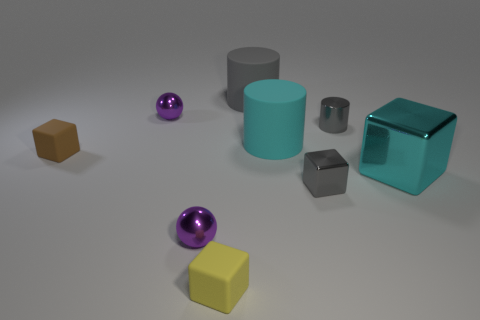Are there any patterns or symmetry in this image? There is no explicit pattern or symmetry in the arrangement of the objects. Each object is distinct in color, shape, and size, contributing to a visually diverse composition that lacks repetitive elements or symmetrical balance. 